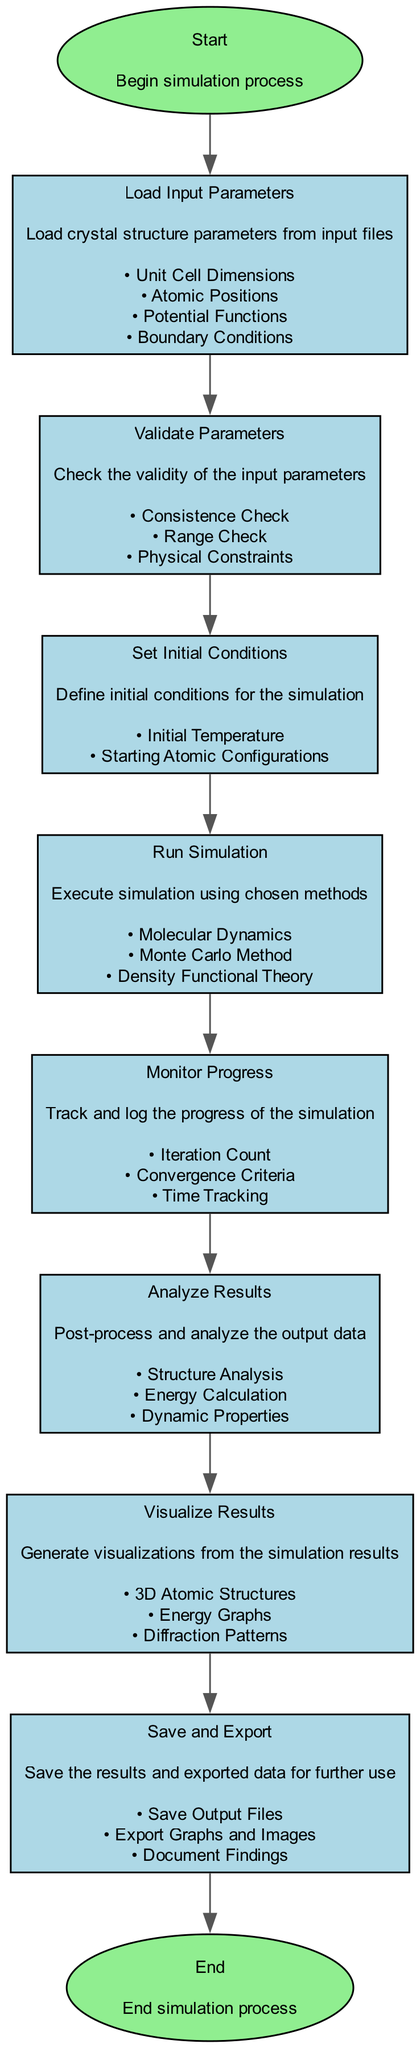What is the first step in the simulation process? The first node in the diagram is labeled "Start," indicating that the simulation process begins here.
Answer: Start How many nodes are present in the diagram? There are a total of 10 nodes present in the flowchart. Each node corresponds to a specific step in the software workflow.
Answer: 10 What is the last step of the process? The final node in the flowchart is labeled "End," signifying the conclusion of the simulation process.
Answer: End What follows the validation of parameters? After the "Validate Parameters" step, the next step is "Set Initial Conditions," which outlines the next actions to take in the workflow.
Answer: Set Initial Conditions Which simulation methods are available in the diagram? The diagram lists three methods: "Molecular Dynamics," "Monte Carlo Method," and "Density Functional Theory," available during the "Run Simulation" step.
Answer: Molecular Dynamics, Monte Carlo Method, Density Functional Theory During which step do you track the simulation's progress? The step labeled "Monitor Progress" is where the tracking and logging of the simulation's progress takes place.
Answer: Monitor Progress What kind of data is processed after running the simulation? The following step post-simulation is "Analyze Results," where the output data is post-processed and analyzed for insights.
Answer: Analyze Results What is the purpose of the "Save and Export" step? In this step, the results and exported data are saved for future use, including output files, graphs, and documentation of findings.
Answer: Save and Export What checks are included in the "Validate Parameters" step? The validation step includes several checks: "Consistence Check," "Range Check," and "Physical Constraints," ensuring the parameters are valid.
Answer: Consistence Check, Range Check, Physical Constraints What visualizations are generated from the simulation results? The "Visualize Results" step includes generating "3D Atomic Structures," "Energy Graphs," and "Diffraction Patterns" as visual aids.
Answer: 3D Atomic Structures, Energy Graphs, Diffraction Patterns 